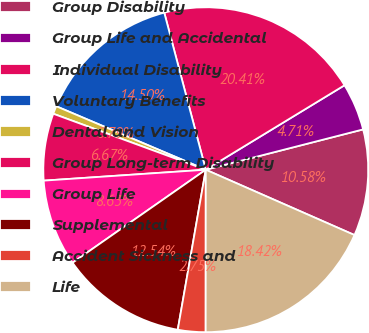Convert chart. <chart><loc_0><loc_0><loc_500><loc_500><pie_chart><fcel>Group Disability<fcel>Group Life and Accidental<fcel>Individual Disability<fcel>Voluntary Benefits<fcel>Dental and Vision<fcel>Group Long-term Disability<fcel>Group Life<fcel>Supplemental<fcel>Accident Sickness and<fcel>Life<nl><fcel>10.58%<fcel>4.71%<fcel>20.41%<fcel>14.5%<fcel>0.79%<fcel>6.67%<fcel>8.63%<fcel>12.54%<fcel>2.75%<fcel>18.42%<nl></chart> 